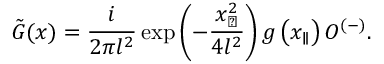Convert formula to latex. <formula><loc_0><loc_0><loc_500><loc_500>\tilde { G } ( x ) = \frac { i } { 2 \pi l ^ { 2 } } \exp \left ( - \frac { x _ { \perp } ^ { 2 } } { 4 l ^ { 2 } } \right ) g \left ( x _ { \| } \right ) O ^ { ( - ) } .</formula> 